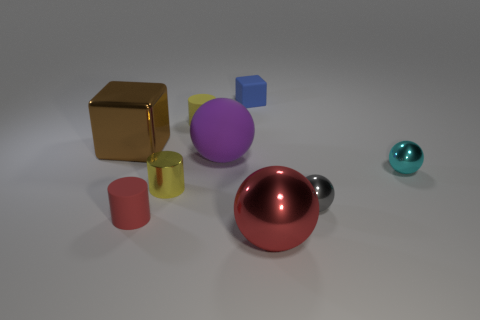What is the shape of the small matte thing that is the same color as the large shiny ball?
Keep it short and to the point. Cylinder. The gray metal thing has what size?
Your answer should be very brief. Small. How many red cylinders are the same size as the brown metal object?
Provide a short and direct response. 0. Is the big block the same color as the big metal ball?
Your response must be concise. No. Is the large object on the left side of the rubber sphere made of the same material as the small red cylinder that is to the left of the small cyan metal ball?
Offer a terse response. No. Is the number of cylinders greater than the number of small red shiny balls?
Your answer should be compact. Yes. Is there anything else that is the same color as the shiny cylinder?
Make the answer very short. Yes. Do the large purple sphere and the small cyan ball have the same material?
Make the answer very short. No. Are there fewer tiny gray balls than tiny brown matte cylinders?
Provide a succinct answer. No. Does the blue object have the same shape as the tiny red object?
Keep it short and to the point. No. 